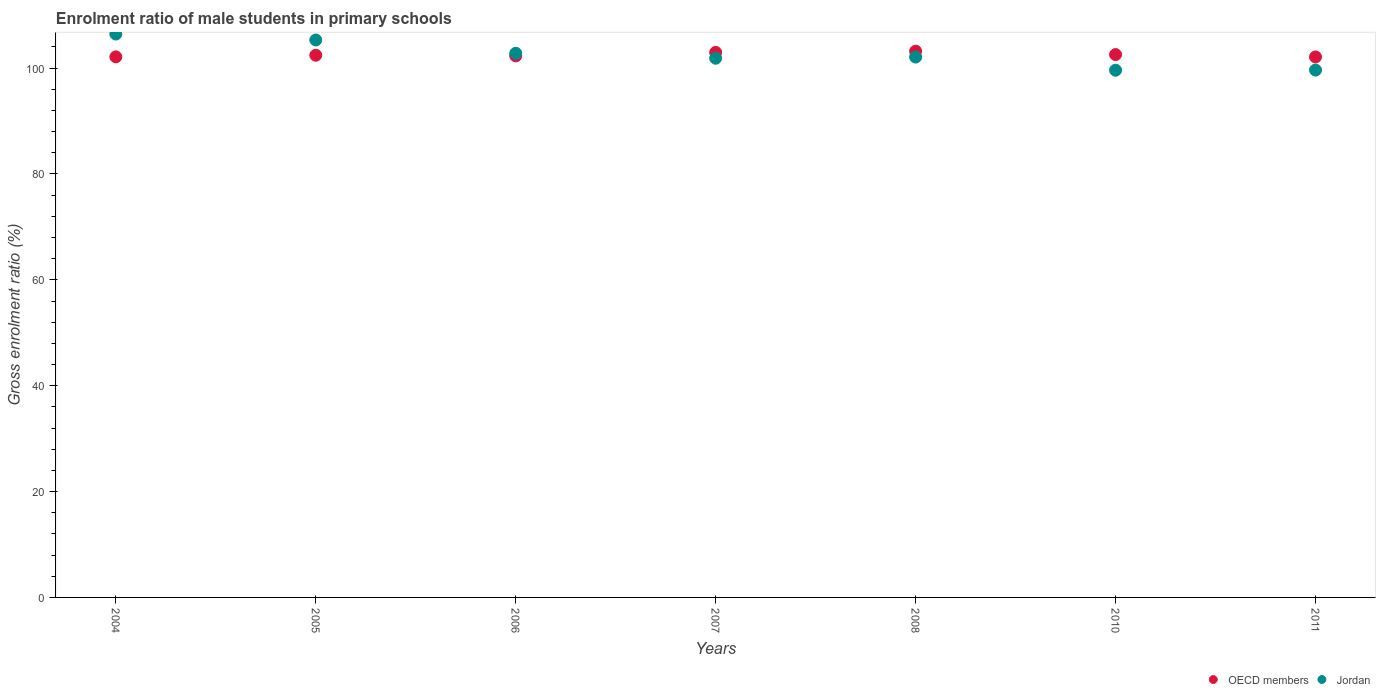Is the number of dotlines equal to the number of legend labels?
Offer a very short reply. Yes. What is the enrolment ratio of male students in primary schools in OECD members in 2011?
Your answer should be compact. 102.11. Across all years, what is the maximum enrolment ratio of male students in primary schools in OECD members?
Your response must be concise. 103.2. Across all years, what is the minimum enrolment ratio of male students in primary schools in OECD members?
Keep it short and to the point. 102.11. In which year was the enrolment ratio of male students in primary schools in Jordan minimum?
Give a very brief answer. 2010. What is the total enrolment ratio of male students in primary schools in OECD members in the graph?
Provide a succinct answer. 717.73. What is the difference between the enrolment ratio of male students in primary schools in OECD members in 2008 and that in 2010?
Give a very brief answer. 0.64. What is the difference between the enrolment ratio of male students in primary schools in OECD members in 2005 and the enrolment ratio of male students in primary schools in Jordan in 2007?
Offer a very short reply. 0.57. What is the average enrolment ratio of male students in primary schools in OECD members per year?
Offer a very short reply. 102.53. In the year 2008, what is the difference between the enrolment ratio of male students in primary schools in OECD members and enrolment ratio of male students in primary schools in Jordan?
Make the answer very short. 1.12. In how many years, is the enrolment ratio of male students in primary schools in Jordan greater than 32 %?
Keep it short and to the point. 7. What is the ratio of the enrolment ratio of male students in primary schools in Jordan in 2005 to that in 2010?
Your response must be concise. 1.06. Is the enrolment ratio of male students in primary schools in OECD members in 2007 less than that in 2008?
Give a very brief answer. Yes. Is the difference between the enrolment ratio of male students in primary schools in OECD members in 2005 and 2011 greater than the difference between the enrolment ratio of male students in primary schools in Jordan in 2005 and 2011?
Keep it short and to the point. No. What is the difference between the highest and the second highest enrolment ratio of male students in primary schools in Jordan?
Offer a very short reply. 1.12. What is the difference between the highest and the lowest enrolment ratio of male students in primary schools in Jordan?
Offer a terse response. 6.83. Is the sum of the enrolment ratio of male students in primary schools in Jordan in 2005 and 2011 greater than the maximum enrolment ratio of male students in primary schools in OECD members across all years?
Provide a succinct answer. Yes. Is the enrolment ratio of male students in primary schools in Jordan strictly greater than the enrolment ratio of male students in primary schools in OECD members over the years?
Keep it short and to the point. No. Is the enrolment ratio of male students in primary schools in OECD members strictly less than the enrolment ratio of male students in primary schools in Jordan over the years?
Give a very brief answer. No. How many dotlines are there?
Provide a short and direct response. 2. What is the difference between two consecutive major ticks on the Y-axis?
Your response must be concise. 20. Where does the legend appear in the graph?
Make the answer very short. Bottom right. How are the legend labels stacked?
Give a very brief answer. Horizontal. What is the title of the graph?
Provide a succinct answer. Enrolment ratio of male students in primary schools. What is the Gross enrolment ratio (%) of OECD members in 2004?
Provide a succinct answer. 102.13. What is the Gross enrolment ratio (%) in Jordan in 2004?
Keep it short and to the point. 106.44. What is the Gross enrolment ratio (%) of OECD members in 2005?
Offer a very short reply. 102.44. What is the Gross enrolment ratio (%) of Jordan in 2005?
Ensure brevity in your answer.  105.32. What is the Gross enrolment ratio (%) of OECD members in 2006?
Provide a short and direct response. 102.31. What is the Gross enrolment ratio (%) of Jordan in 2006?
Make the answer very short. 102.81. What is the Gross enrolment ratio (%) of OECD members in 2007?
Ensure brevity in your answer.  102.97. What is the Gross enrolment ratio (%) of Jordan in 2007?
Your response must be concise. 101.87. What is the Gross enrolment ratio (%) in OECD members in 2008?
Your answer should be compact. 103.2. What is the Gross enrolment ratio (%) in Jordan in 2008?
Keep it short and to the point. 102.09. What is the Gross enrolment ratio (%) of OECD members in 2010?
Make the answer very short. 102.56. What is the Gross enrolment ratio (%) of Jordan in 2010?
Keep it short and to the point. 99.61. What is the Gross enrolment ratio (%) in OECD members in 2011?
Keep it short and to the point. 102.11. What is the Gross enrolment ratio (%) in Jordan in 2011?
Your answer should be very brief. 99.63. Across all years, what is the maximum Gross enrolment ratio (%) of OECD members?
Provide a short and direct response. 103.2. Across all years, what is the maximum Gross enrolment ratio (%) in Jordan?
Make the answer very short. 106.44. Across all years, what is the minimum Gross enrolment ratio (%) of OECD members?
Your response must be concise. 102.11. Across all years, what is the minimum Gross enrolment ratio (%) in Jordan?
Make the answer very short. 99.61. What is the total Gross enrolment ratio (%) in OECD members in the graph?
Offer a terse response. 717.73. What is the total Gross enrolment ratio (%) of Jordan in the graph?
Your answer should be compact. 717.76. What is the difference between the Gross enrolment ratio (%) in OECD members in 2004 and that in 2005?
Offer a terse response. -0.3. What is the difference between the Gross enrolment ratio (%) in Jordan in 2004 and that in 2005?
Your answer should be compact. 1.12. What is the difference between the Gross enrolment ratio (%) of OECD members in 2004 and that in 2006?
Your answer should be compact. -0.18. What is the difference between the Gross enrolment ratio (%) in Jordan in 2004 and that in 2006?
Ensure brevity in your answer.  3.63. What is the difference between the Gross enrolment ratio (%) in OECD members in 2004 and that in 2007?
Your response must be concise. -0.84. What is the difference between the Gross enrolment ratio (%) of Jordan in 2004 and that in 2007?
Your answer should be compact. 4.57. What is the difference between the Gross enrolment ratio (%) in OECD members in 2004 and that in 2008?
Provide a succinct answer. -1.07. What is the difference between the Gross enrolment ratio (%) in Jordan in 2004 and that in 2008?
Make the answer very short. 4.35. What is the difference between the Gross enrolment ratio (%) in OECD members in 2004 and that in 2010?
Provide a short and direct response. -0.43. What is the difference between the Gross enrolment ratio (%) in Jordan in 2004 and that in 2010?
Offer a very short reply. 6.83. What is the difference between the Gross enrolment ratio (%) of OECD members in 2004 and that in 2011?
Make the answer very short. 0.02. What is the difference between the Gross enrolment ratio (%) of Jordan in 2004 and that in 2011?
Offer a terse response. 6.8. What is the difference between the Gross enrolment ratio (%) of OECD members in 2005 and that in 2006?
Ensure brevity in your answer.  0.12. What is the difference between the Gross enrolment ratio (%) of Jordan in 2005 and that in 2006?
Your answer should be compact. 2.51. What is the difference between the Gross enrolment ratio (%) in OECD members in 2005 and that in 2007?
Offer a terse response. -0.54. What is the difference between the Gross enrolment ratio (%) in Jordan in 2005 and that in 2007?
Your response must be concise. 3.45. What is the difference between the Gross enrolment ratio (%) in OECD members in 2005 and that in 2008?
Offer a terse response. -0.77. What is the difference between the Gross enrolment ratio (%) of Jordan in 2005 and that in 2008?
Your answer should be very brief. 3.23. What is the difference between the Gross enrolment ratio (%) of OECD members in 2005 and that in 2010?
Your answer should be compact. -0.12. What is the difference between the Gross enrolment ratio (%) of Jordan in 2005 and that in 2010?
Your response must be concise. 5.71. What is the difference between the Gross enrolment ratio (%) in OECD members in 2005 and that in 2011?
Your response must be concise. 0.32. What is the difference between the Gross enrolment ratio (%) in Jordan in 2005 and that in 2011?
Your answer should be compact. 5.68. What is the difference between the Gross enrolment ratio (%) in OECD members in 2006 and that in 2007?
Offer a very short reply. -0.66. What is the difference between the Gross enrolment ratio (%) of Jordan in 2006 and that in 2007?
Ensure brevity in your answer.  0.94. What is the difference between the Gross enrolment ratio (%) in OECD members in 2006 and that in 2008?
Provide a short and direct response. -0.89. What is the difference between the Gross enrolment ratio (%) of Jordan in 2006 and that in 2008?
Provide a short and direct response. 0.72. What is the difference between the Gross enrolment ratio (%) in OECD members in 2006 and that in 2010?
Your answer should be compact. -0.25. What is the difference between the Gross enrolment ratio (%) in Jordan in 2006 and that in 2010?
Provide a succinct answer. 3.2. What is the difference between the Gross enrolment ratio (%) in OECD members in 2006 and that in 2011?
Your answer should be very brief. 0.2. What is the difference between the Gross enrolment ratio (%) of Jordan in 2006 and that in 2011?
Offer a very short reply. 3.18. What is the difference between the Gross enrolment ratio (%) in OECD members in 2007 and that in 2008?
Give a very brief answer. -0.23. What is the difference between the Gross enrolment ratio (%) in Jordan in 2007 and that in 2008?
Make the answer very short. -0.22. What is the difference between the Gross enrolment ratio (%) of OECD members in 2007 and that in 2010?
Ensure brevity in your answer.  0.41. What is the difference between the Gross enrolment ratio (%) in Jordan in 2007 and that in 2010?
Give a very brief answer. 2.26. What is the difference between the Gross enrolment ratio (%) in OECD members in 2007 and that in 2011?
Provide a short and direct response. 0.86. What is the difference between the Gross enrolment ratio (%) in Jordan in 2007 and that in 2011?
Make the answer very short. 2.23. What is the difference between the Gross enrolment ratio (%) of OECD members in 2008 and that in 2010?
Provide a succinct answer. 0.64. What is the difference between the Gross enrolment ratio (%) in Jordan in 2008 and that in 2010?
Provide a short and direct response. 2.48. What is the difference between the Gross enrolment ratio (%) in OECD members in 2008 and that in 2011?
Your response must be concise. 1.09. What is the difference between the Gross enrolment ratio (%) of Jordan in 2008 and that in 2011?
Your answer should be compact. 2.45. What is the difference between the Gross enrolment ratio (%) in OECD members in 2010 and that in 2011?
Offer a very short reply. 0.45. What is the difference between the Gross enrolment ratio (%) of Jordan in 2010 and that in 2011?
Keep it short and to the point. -0.03. What is the difference between the Gross enrolment ratio (%) of OECD members in 2004 and the Gross enrolment ratio (%) of Jordan in 2005?
Make the answer very short. -3.18. What is the difference between the Gross enrolment ratio (%) in OECD members in 2004 and the Gross enrolment ratio (%) in Jordan in 2006?
Give a very brief answer. -0.68. What is the difference between the Gross enrolment ratio (%) in OECD members in 2004 and the Gross enrolment ratio (%) in Jordan in 2007?
Keep it short and to the point. 0.26. What is the difference between the Gross enrolment ratio (%) in OECD members in 2004 and the Gross enrolment ratio (%) in Jordan in 2008?
Your answer should be very brief. 0.04. What is the difference between the Gross enrolment ratio (%) of OECD members in 2004 and the Gross enrolment ratio (%) of Jordan in 2010?
Give a very brief answer. 2.53. What is the difference between the Gross enrolment ratio (%) in OECD members in 2004 and the Gross enrolment ratio (%) in Jordan in 2011?
Your answer should be compact. 2.5. What is the difference between the Gross enrolment ratio (%) in OECD members in 2005 and the Gross enrolment ratio (%) in Jordan in 2006?
Provide a short and direct response. -0.37. What is the difference between the Gross enrolment ratio (%) of OECD members in 2005 and the Gross enrolment ratio (%) of Jordan in 2007?
Your answer should be very brief. 0.57. What is the difference between the Gross enrolment ratio (%) in OECD members in 2005 and the Gross enrolment ratio (%) in Jordan in 2008?
Provide a short and direct response. 0.35. What is the difference between the Gross enrolment ratio (%) of OECD members in 2005 and the Gross enrolment ratio (%) of Jordan in 2010?
Keep it short and to the point. 2.83. What is the difference between the Gross enrolment ratio (%) in OECD members in 2005 and the Gross enrolment ratio (%) in Jordan in 2011?
Provide a succinct answer. 2.8. What is the difference between the Gross enrolment ratio (%) of OECD members in 2006 and the Gross enrolment ratio (%) of Jordan in 2007?
Your answer should be compact. 0.44. What is the difference between the Gross enrolment ratio (%) of OECD members in 2006 and the Gross enrolment ratio (%) of Jordan in 2008?
Offer a terse response. 0.23. What is the difference between the Gross enrolment ratio (%) of OECD members in 2006 and the Gross enrolment ratio (%) of Jordan in 2010?
Give a very brief answer. 2.71. What is the difference between the Gross enrolment ratio (%) in OECD members in 2006 and the Gross enrolment ratio (%) in Jordan in 2011?
Keep it short and to the point. 2.68. What is the difference between the Gross enrolment ratio (%) in OECD members in 2007 and the Gross enrolment ratio (%) in Jordan in 2008?
Offer a terse response. 0.88. What is the difference between the Gross enrolment ratio (%) of OECD members in 2007 and the Gross enrolment ratio (%) of Jordan in 2010?
Your answer should be compact. 3.37. What is the difference between the Gross enrolment ratio (%) of OECD members in 2007 and the Gross enrolment ratio (%) of Jordan in 2011?
Make the answer very short. 3.34. What is the difference between the Gross enrolment ratio (%) of OECD members in 2008 and the Gross enrolment ratio (%) of Jordan in 2010?
Keep it short and to the point. 3.6. What is the difference between the Gross enrolment ratio (%) in OECD members in 2008 and the Gross enrolment ratio (%) in Jordan in 2011?
Your answer should be compact. 3.57. What is the difference between the Gross enrolment ratio (%) in OECD members in 2010 and the Gross enrolment ratio (%) in Jordan in 2011?
Provide a succinct answer. 2.93. What is the average Gross enrolment ratio (%) in OECD members per year?
Your answer should be very brief. 102.53. What is the average Gross enrolment ratio (%) of Jordan per year?
Ensure brevity in your answer.  102.54. In the year 2004, what is the difference between the Gross enrolment ratio (%) in OECD members and Gross enrolment ratio (%) in Jordan?
Offer a very short reply. -4.3. In the year 2005, what is the difference between the Gross enrolment ratio (%) in OECD members and Gross enrolment ratio (%) in Jordan?
Keep it short and to the point. -2.88. In the year 2006, what is the difference between the Gross enrolment ratio (%) in OECD members and Gross enrolment ratio (%) in Jordan?
Your response must be concise. -0.5. In the year 2007, what is the difference between the Gross enrolment ratio (%) in OECD members and Gross enrolment ratio (%) in Jordan?
Offer a very short reply. 1.1. In the year 2008, what is the difference between the Gross enrolment ratio (%) of OECD members and Gross enrolment ratio (%) of Jordan?
Keep it short and to the point. 1.12. In the year 2010, what is the difference between the Gross enrolment ratio (%) in OECD members and Gross enrolment ratio (%) in Jordan?
Your answer should be compact. 2.96. In the year 2011, what is the difference between the Gross enrolment ratio (%) in OECD members and Gross enrolment ratio (%) in Jordan?
Offer a very short reply. 2.48. What is the ratio of the Gross enrolment ratio (%) of Jordan in 2004 to that in 2005?
Give a very brief answer. 1.01. What is the ratio of the Gross enrolment ratio (%) in OECD members in 2004 to that in 2006?
Give a very brief answer. 1. What is the ratio of the Gross enrolment ratio (%) in Jordan in 2004 to that in 2006?
Offer a terse response. 1.04. What is the ratio of the Gross enrolment ratio (%) of OECD members in 2004 to that in 2007?
Provide a short and direct response. 0.99. What is the ratio of the Gross enrolment ratio (%) in Jordan in 2004 to that in 2007?
Provide a succinct answer. 1.04. What is the ratio of the Gross enrolment ratio (%) of OECD members in 2004 to that in 2008?
Offer a terse response. 0.99. What is the ratio of the Gross enrolment ratio (%) of Jordan in 2004 to that in 2008?
Offer a terse response. 1.04. What is the ratio of the Gross enrolment ratio (%) in Jordan in 2004 to that in 2010?
Your response must be concise. 1.07. What is the ratio of the Gross enrolment ratio (%) of Jordan in 2004 to that in 2011?
Offer a terse response. 1.07. What is the ratio of the Gross enrolment ratio (%) of Jordan in 2005 to that in 2006?
Your answer should be very brief. 1.02. What is the ratio of the Gross enrolment ratio (%) of OECD members in 2005 to that in 2007?
Provide a succinct answer. 0.99. What is the ratio of the Gross enrolment ratio (%) of Jordan in 2005 to that in 2007?
Keep it short and to the point. 1.03. What is the ratio of the Gross enrolment ratio (%) in Jordan in 2005 to that in 2008?
Give a very brief answer. 1.03. What is the ratio of the Gross enrolment ratio (%) in Jordan in 2005 to that in 2010?
Keep it short and to the point. 1.06. What is the ratio of the Gross enrolment ratio (%) in OECD members in 2005 to that in 2011?
Offer a very short reply. 1. What is the ratio of the Gross enrolment ratio (%) in Jordan in 2005 to that in 2011?
Your answer should be compact. 1.06. What is the ratio of the Gross enrolment ratio (%) in OECD members in 2006 to that in 2007?
Keep it short and to the point. 0.99. What is the ratio of the Gross enrolment ratio (%) of Jordan in 2006 to that in 2007?
Offer a very short reply. 1.01. What is the ratio of the Gross enrolment ratio (%) in Jordan in 2006 to that in 2008?
Your response must be concise. 1.01. What is the ratio of the Gross enrolment ratio (%) in OECD members in 2006 to that in 2010?
Offer a terse response. 1. What is the ratio of the Gross enrolment ratio (%) in Jordan in 2006 to that in 2010?
Your response must be concise. 1.03. What is the ratio of the Gross enrolment ratio (%) in OECD members in 2006 to that in 2011?
Make the answer very short. 1. What is the ratio of the Gross enrolment ratio (%) of Jordan in 2006 to that in 2011?
Your response must be concise. 1.03. What is the ratio of the Gross enrolment ratio (%) of Jordan in 2007 to that in 2010?
Give a very brief answer. 1.02. What is the ratio of the Gross enrolment ratio (%) in OECD members in 2007 to that in 2011?
Provide a succinct answer. 1.01. What is the ratio of the Gross enrolment ratio (%) in Jordan in 2007 to that in 2011?
Your response must be concise. 1.02. What is the ratio of the Gross enrolment ratio (%) in Jordan in 2008 to that in 2010?
Your response must be concise. 1.02. What is the ratio of the Gross enrolment ratio (%) of OECD members in 2008 to that in 2011?
Give a very brief answer. 1.01. What is the ratio of the Gross enrolment ratio (%) in Jordan in 2008 to that in 2011?
Make the answer very short. 1.02. What is the ratio of the Gross enrolment ratio (%) in OECD members in 2010 to that in 2011?
Give a very brief answer. 1. What is the difference between the highest and the second highest Gross enrolment ratio (%) of OECD members?
Your answer should be compact. 0.23. What is the difference between the highest and the second highest Gross enrolment ratio (%) in Jordan?
Your answer should be very brief. 1.12. What is the difference between the highest and the lowest Gross enrolment ratio (%) of OECD members?
Your answer should be compact. 1.09. What is the difference between the highest and the lowest Gross enrolment ratio (%) in Jordan?
Keep it short and to the point. 6.83. 